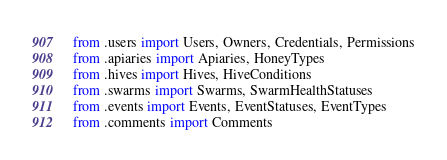<code> <loc_0><loc_0><loc_500><loc_500><_Python_>from .users import Users, Owners, Credentials, Permissions
from .apiaries import Apiaries, HoneyTypes
from .hives import Hives, HiveConditions
from .swarms import Swarms, SwarmHealthStatuses
from .events import Events, EventStatuses, EventTypes
from .comments import Comments
</code> 